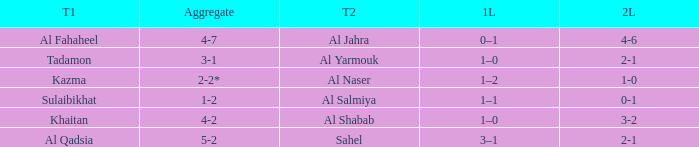What is the 1st leg of the match with a 2nd leg of 3-2? 1–0. 